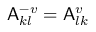Convert formula to latex. <formula><loc_0><loc_0><loc_500><loc_500>A _ { k l } ^ { - v } = A _ { l k } ^ { v }</formula> 